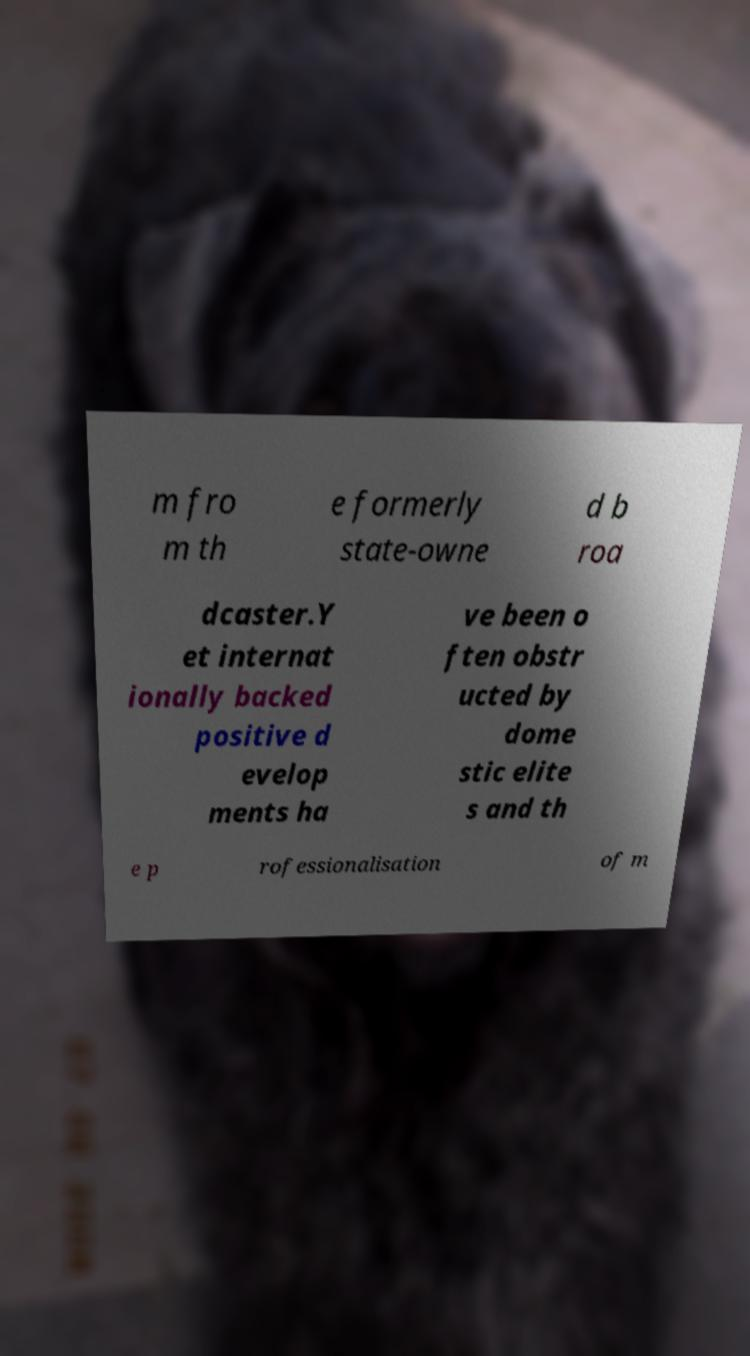Can you accurately transcribe the text from the provided image for me? m fro m th e formerly state-owne d b roa dcaster.Y et internat ionally backed positive d evelop ments ha ve been o ften obstr ucted by dome stic elite s and th e p rofessionalisation of m 